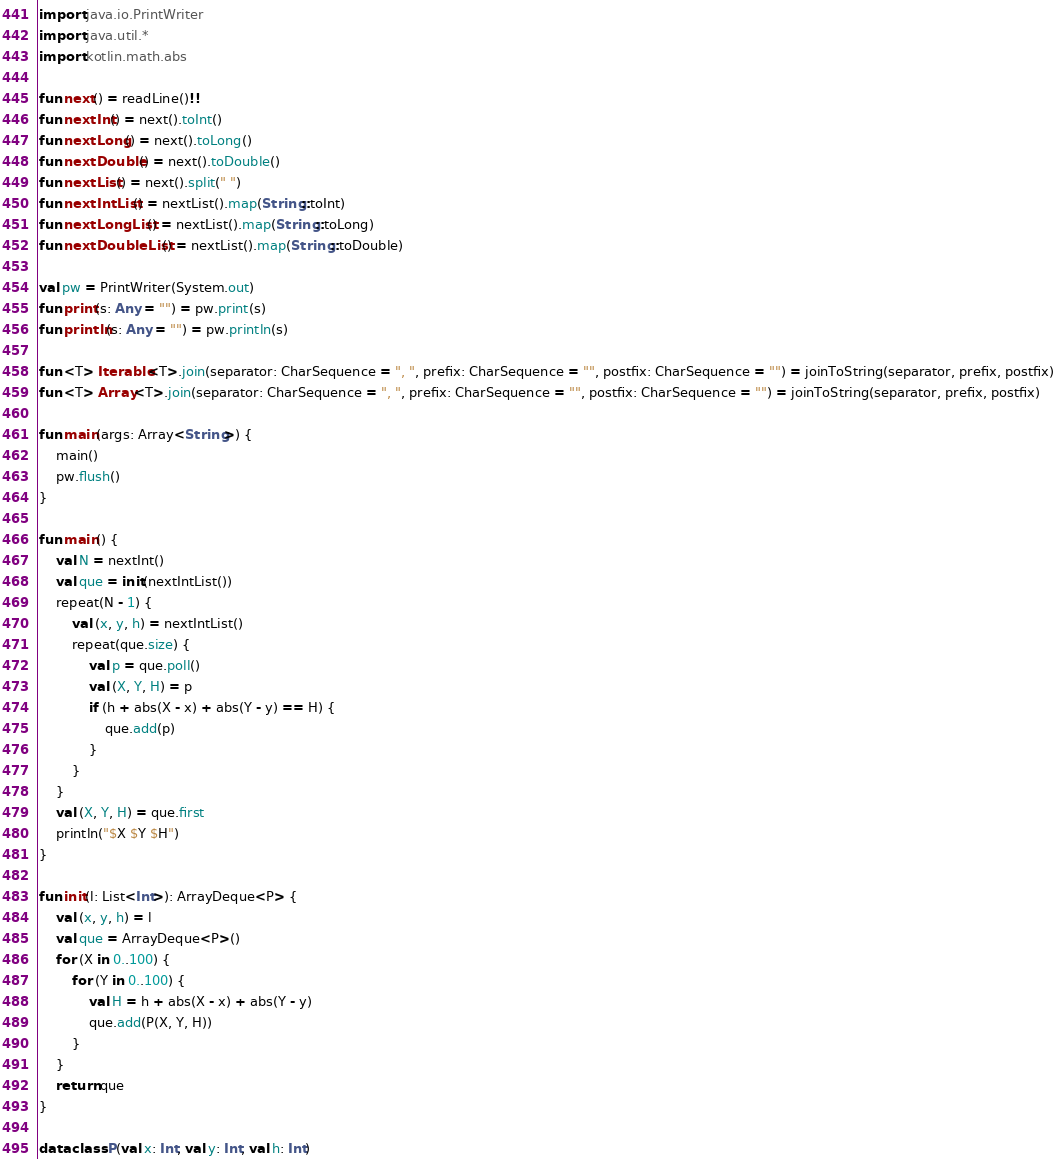Convert code to text. <code><loc_0><loc_0><loc_500><loc_500><_Kotlin_>import java.io.PrintWriter
import java.util.*
import kotlin.math.abs

fun next() = readLine()!!
fun nextInt() = next().toInt()
fun nextLong() = next().toLong()
fun nextDouble() = next().toDouble()
fun nextList() = next().split(" ")
fun nextIntList() = nextList().map(String::toInt)
fun nextLongList() = nextList().map(String::toLong)
fun nextDoubleList() = nextList().map(String::toDouble)

val pw = PrintWriter(System.out)
fun print(s: Any = "") = pw.print(s)
fun println(s: Any = "") = pw.println(s)

fun <T> Iterable<T>.join(separator: CharSequence = ", ", prefix: CharSequence = "", postfix: CharSequence = "") = joinToString(separator, prefix, postfix)
fun <T> Array<T>.join(separator: CharSequence = ", ", prefix: CharSequence = "", postfix: CharSequence = "") = joinToString(separator, prefix, postfix)

fun main(args: Array<String>) {
    main()
    pw.flush()
}

fun main() {
    val N = nextInt()
    val que = init(nextIntList())
    repeat(N - 1) {
        val (x, y, h) = nextIntList()
        repeat(que.size) {
            val p = que.poll()
            val (X, Y, H) = p
            if (h + abs(X - x) + abs(Y - y) == H) {
                que.add(p)
            }
        }
    }
    val (X, Y, H) = que.first
    println("$X $Y $H")
}

fun init(l: List<Int>): ArrayDeque<P> {
    val (x, y, h) = l
    val que = ArrayDeque<P>()
    for (X in 0..100) {
        for (Y in 0..100) {
            val H = h + abs(X - x) + abs(Y - y)
            que.add(P(X, Y, H))
        }
    }
    return que
}

data class P(val x: Int, val y: Int, val h: Int)</code> 